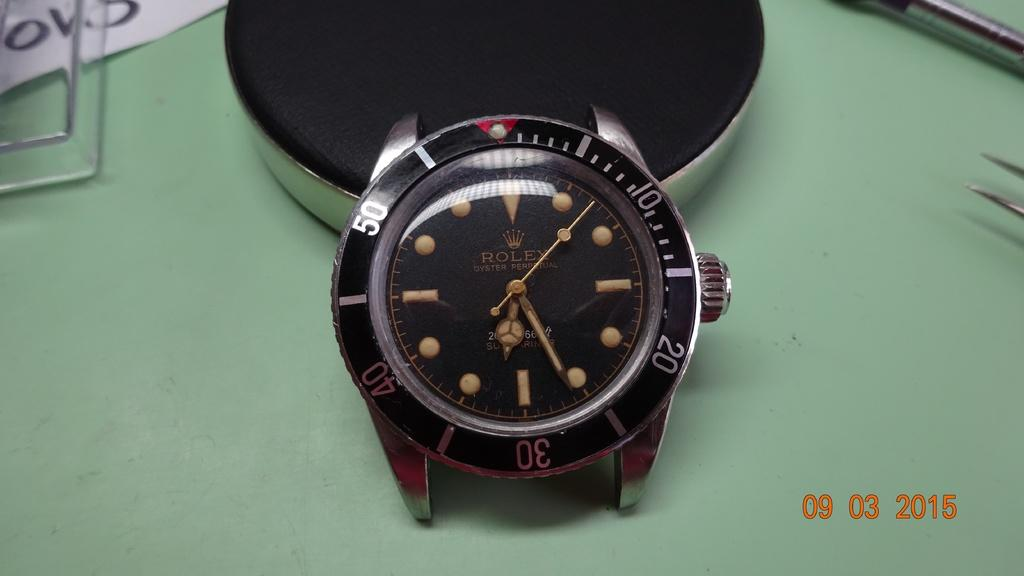<image>
Offer a succinct explanation of the picture presented. A Rolex watch with no band and no numbers on the watch face is placed on a green table. 